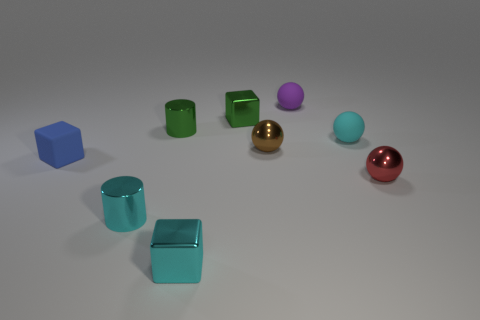Describe the lighting and shadows in the scene. The image is softly lit from the upper left, resulting in moderate shadows to the lower right of each object. This lighting suggests a single diffuse light source, giving the scene a calm and even ambiance. 